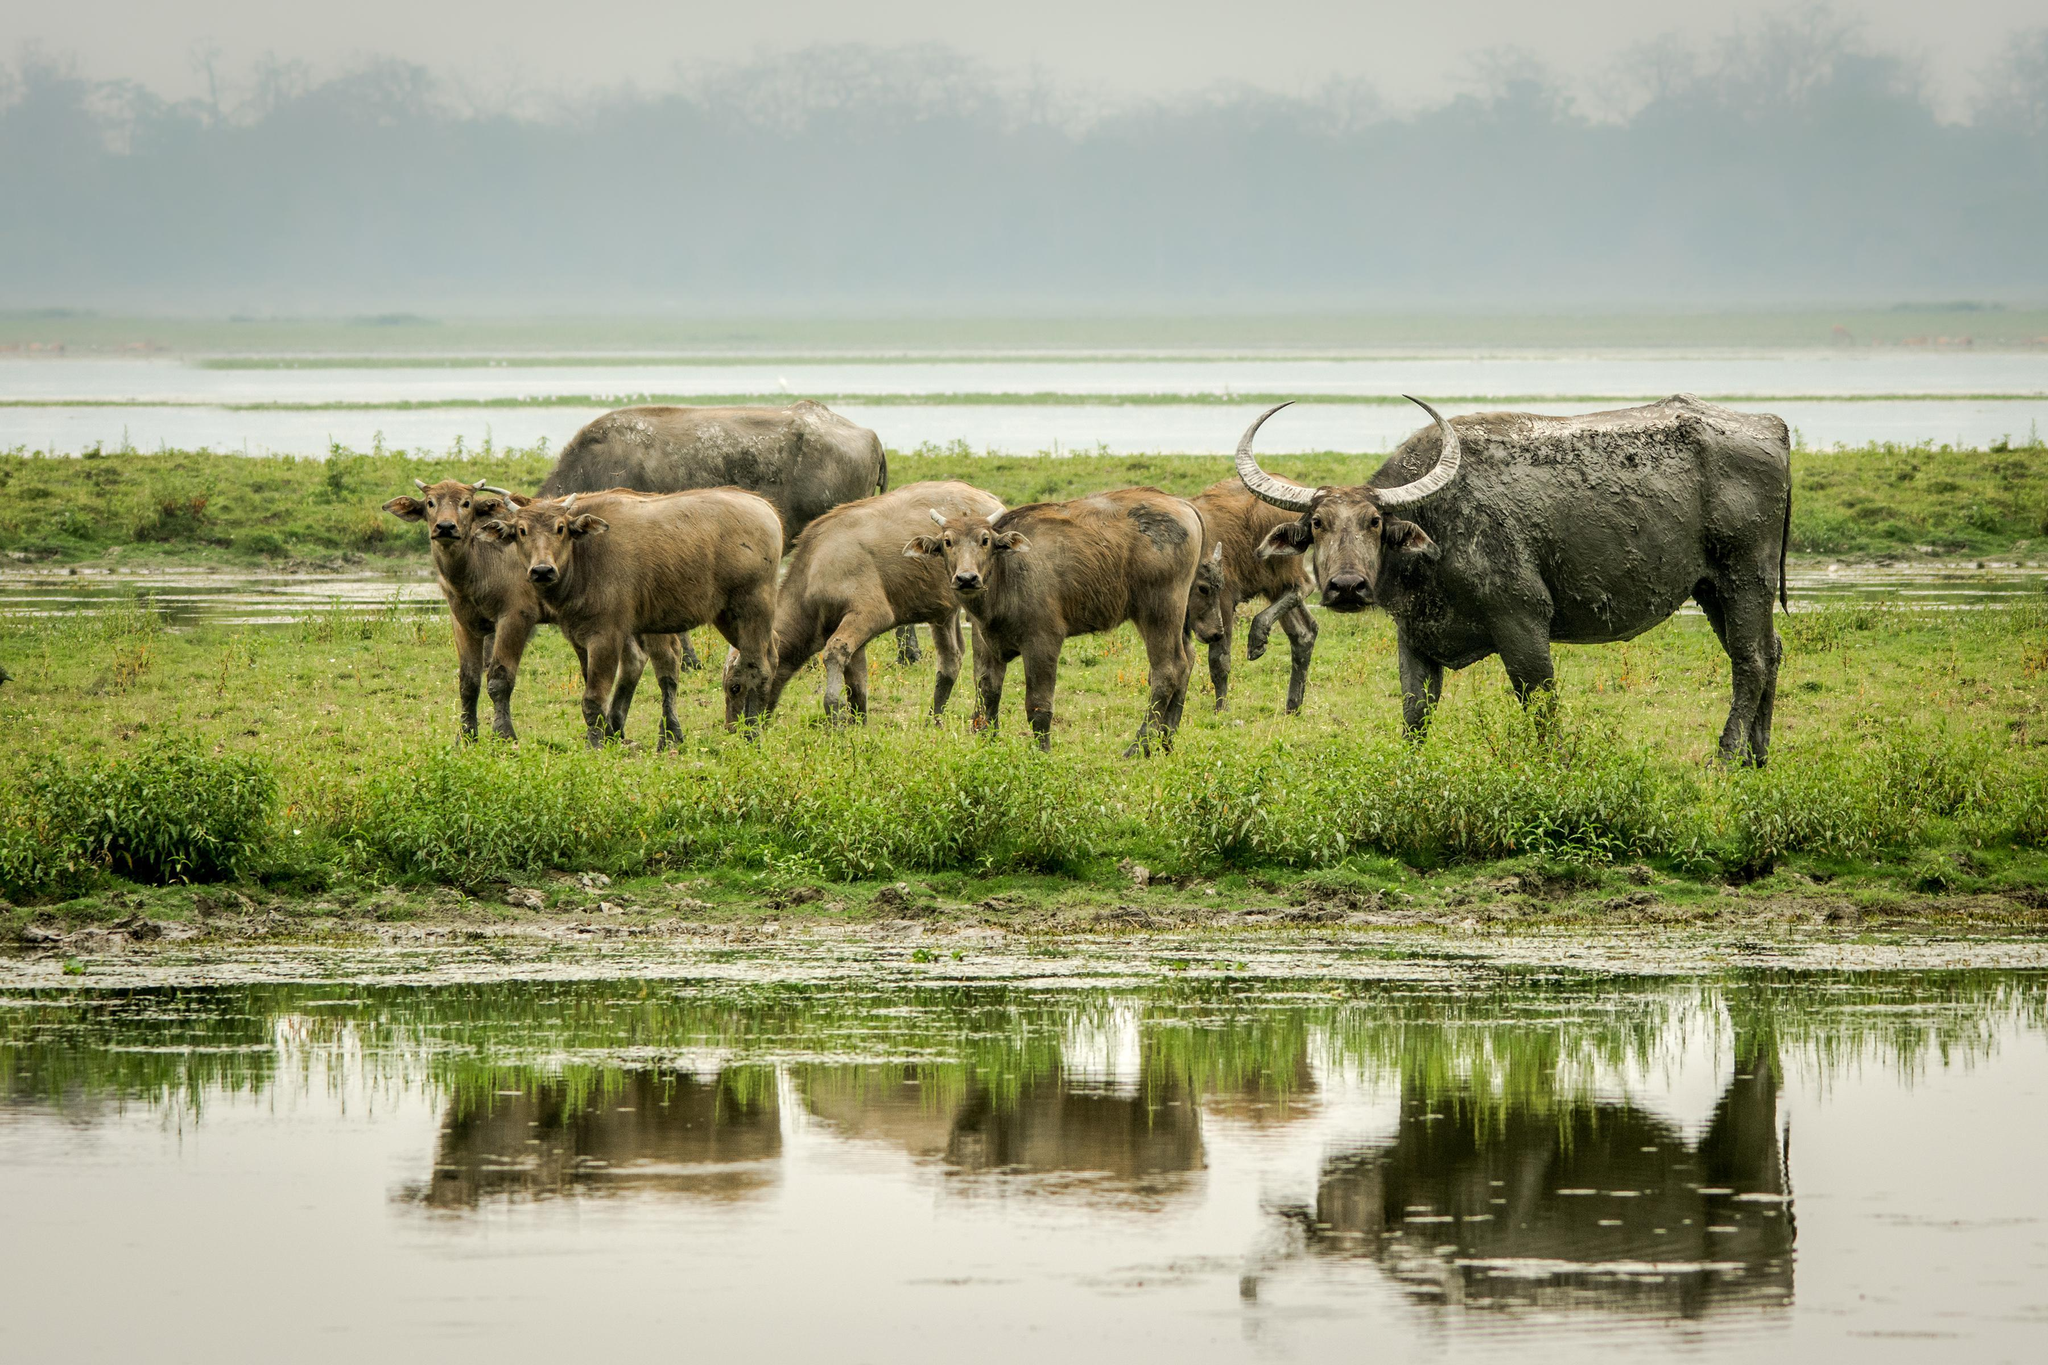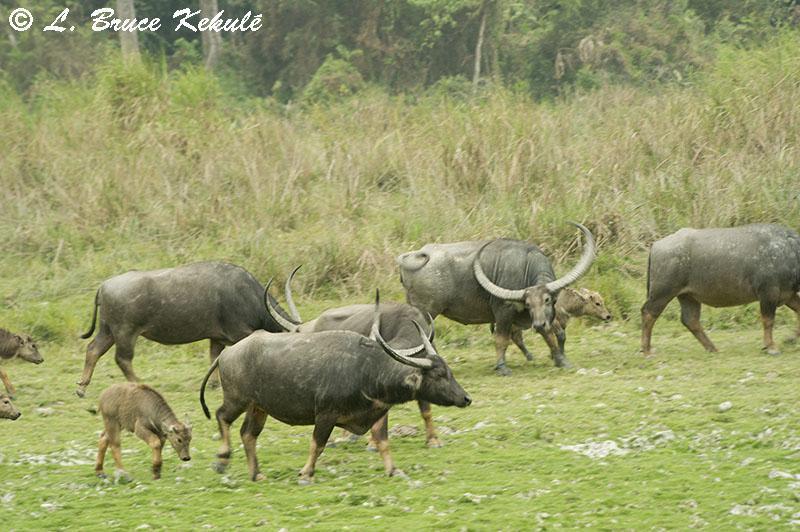The first image is the image on the left, the second image is the image on the right. Assess this claim about the two images: "The animals in the image on the left are near an area of water.". Correct or not? Answer yes or no. Yes. The first image is the image on the left, the second image is the image on the right. Assess this claim about the two images: "An image shows exactly two water buffalo standing in profile.". Correct or not? Answer yes or no. No. 